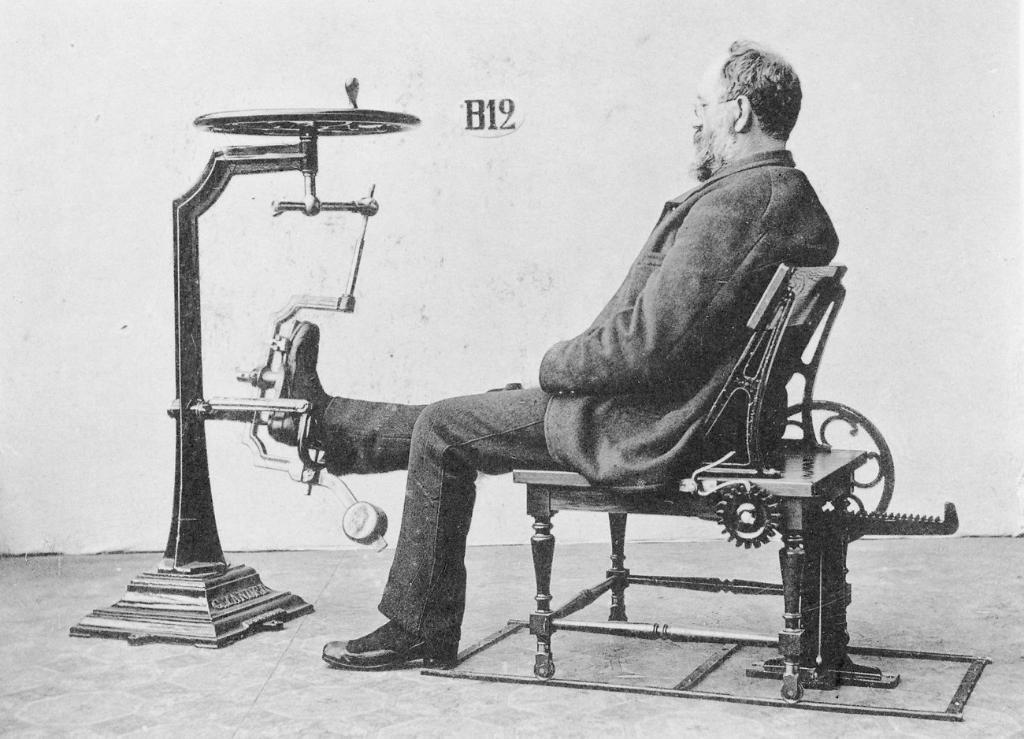What is the color of the wall in the image? The wall in the image is white. What is the man in the image doing? The man is sitting on a chair in the image. What is the purpose of the boot in the image? There is no boot present in the image. What type of food is the man eating for breakfast in the image? The image does not show the man eating any food, so it cannot be determined what he might be eating for breakfast. 